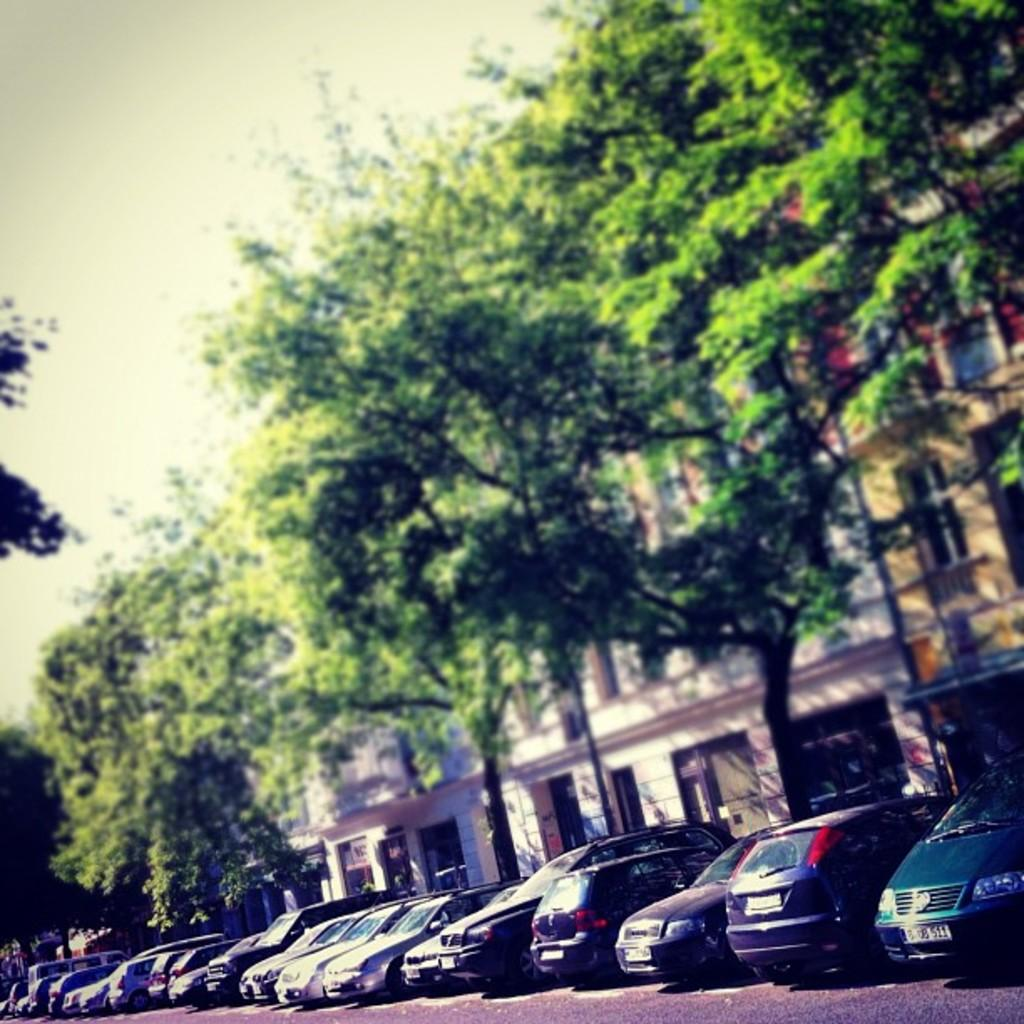What is the main subject in the center of the image? There are vehicles in the center of the image. What can be seen in the background of the image? There is sky, trees, and buildings visible in the background of the image. What type of doctor can be seen treating patients in the image? There is no doctor present in the image; it features vehicles and a background with sky, trees, and buildings. 